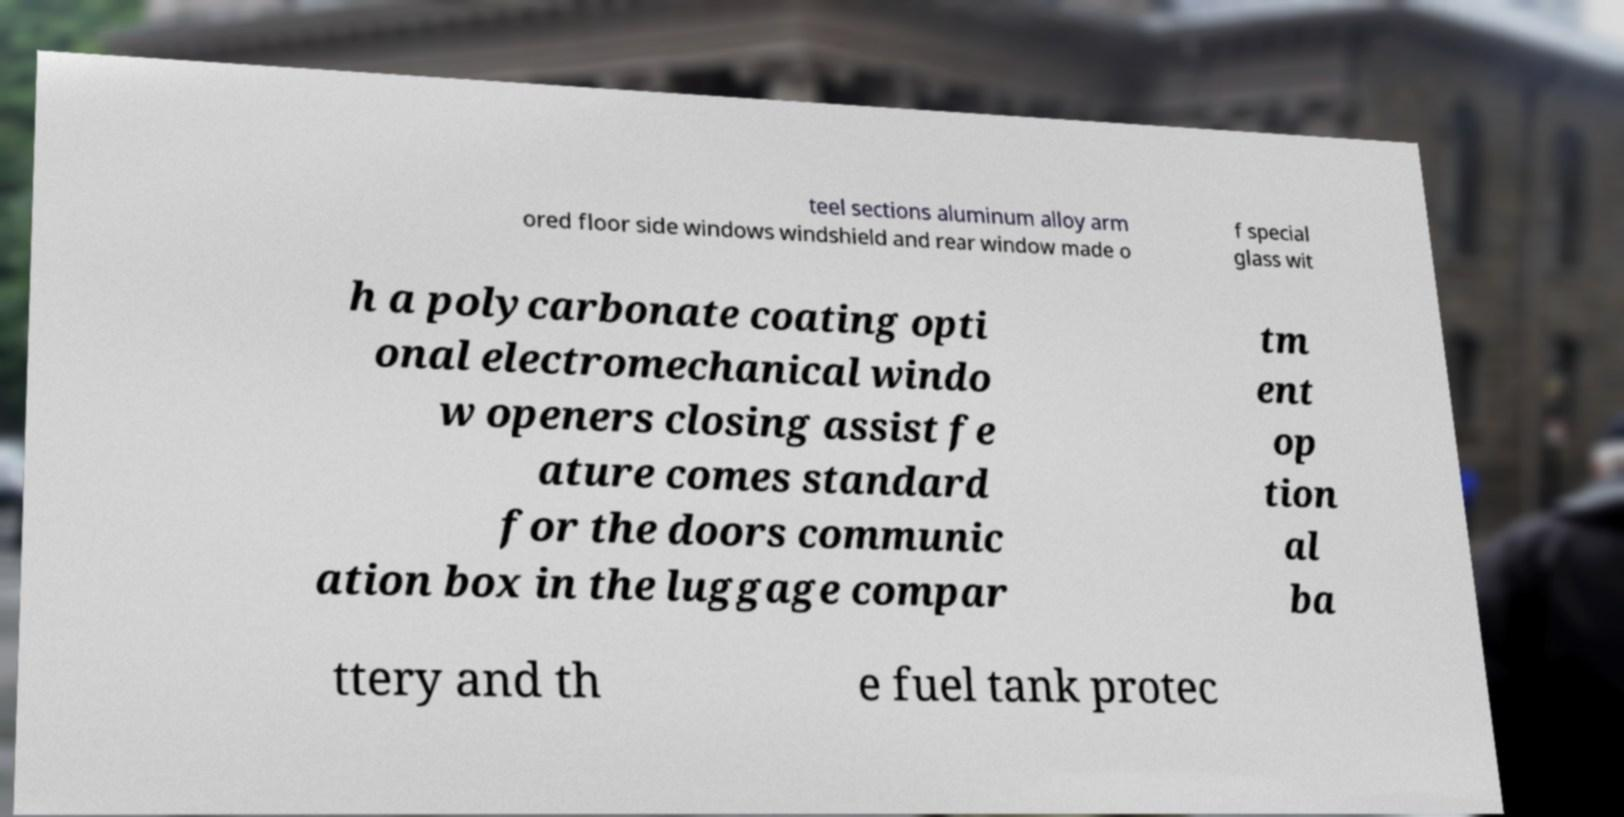There's text embedded in this image that I need extracted. Can you transcribe it verbatim? teel sections aluminum alloy arm ored floor side windows windshield and rear window made o f special glass wit h a polycarbonate coating opti onal electromechanical windo w openers closing assist fe ature comes standard for the doors communic ation box in the luggage compar tm ent op tion al ba ttery and th e fuel tank protec 